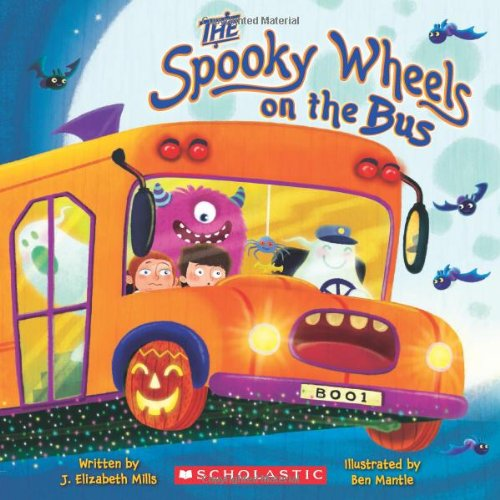Is this a kids book? Yes, this book is targeting children, particularly those interested in enjoyable and slightly spooky stories, making it a perfect read around Halloween. 